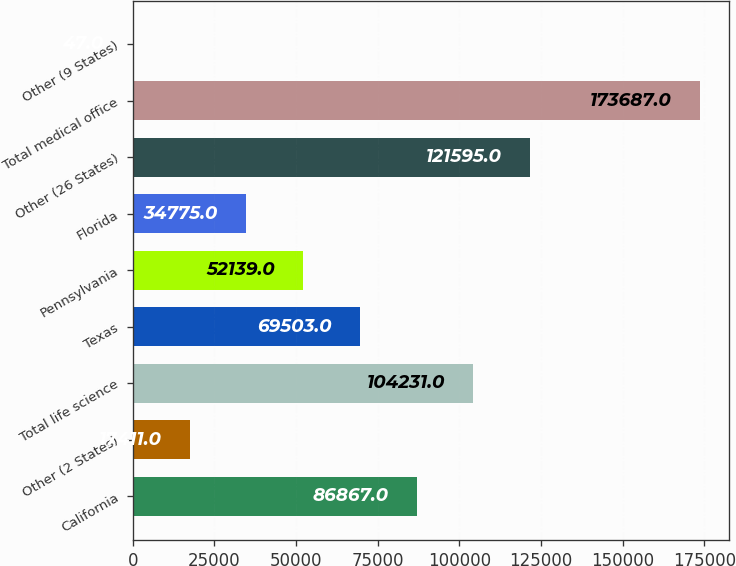<chart> <loc_0><loc_0><loc_500><loc_500><bar_chart><fcel>California<fcel>Other (2 States)<fcel>Total life science<fcel>Texas<fcel>Pennsylvania<fcel>Florida<fcel>Other (26 States)<fcel>Total medical office<fcel>Other (9 States)<nl><fcel>86867<fcel>17411<fcel>104231<fcel>69503<fcel>52139<fcel>34775<fcel>121595<fcel>173687<fcel>47<nl></chart> 